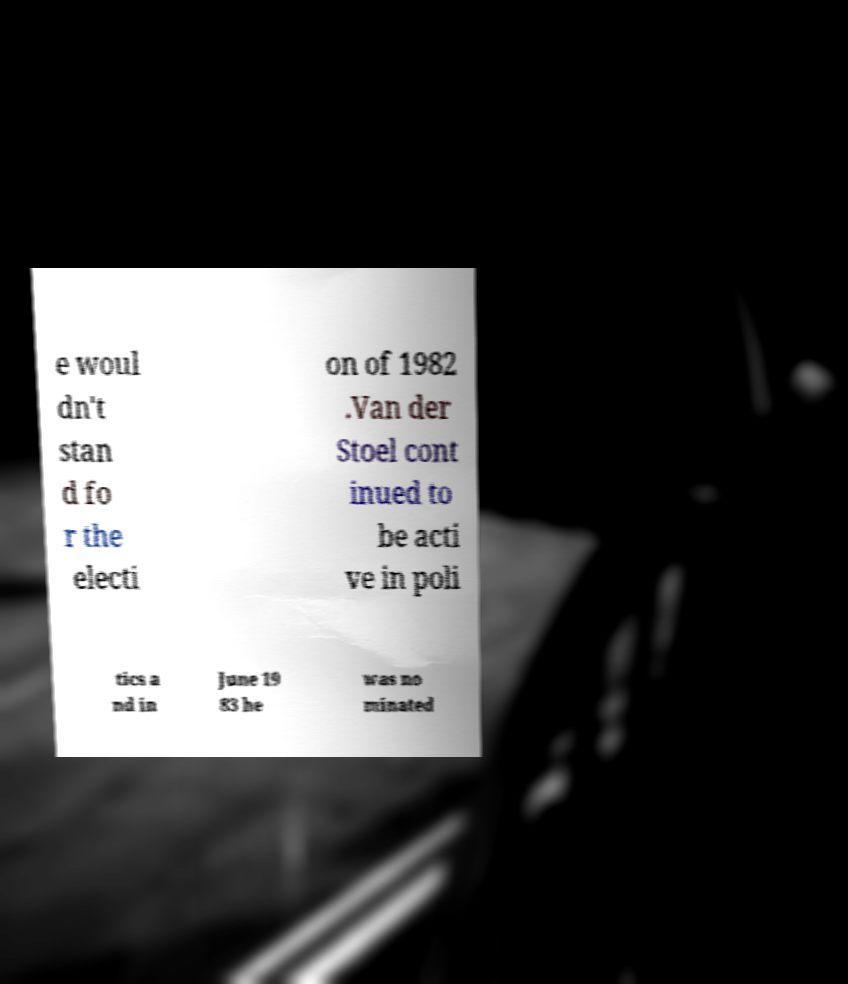I need the written content from this picture converted into text. Can you do that? e woul dn't stan d fo r the electi on of 1982 .Van der Stoel cont inued to be acti ve in poli tics a nd in June 19 83 he was no minated 